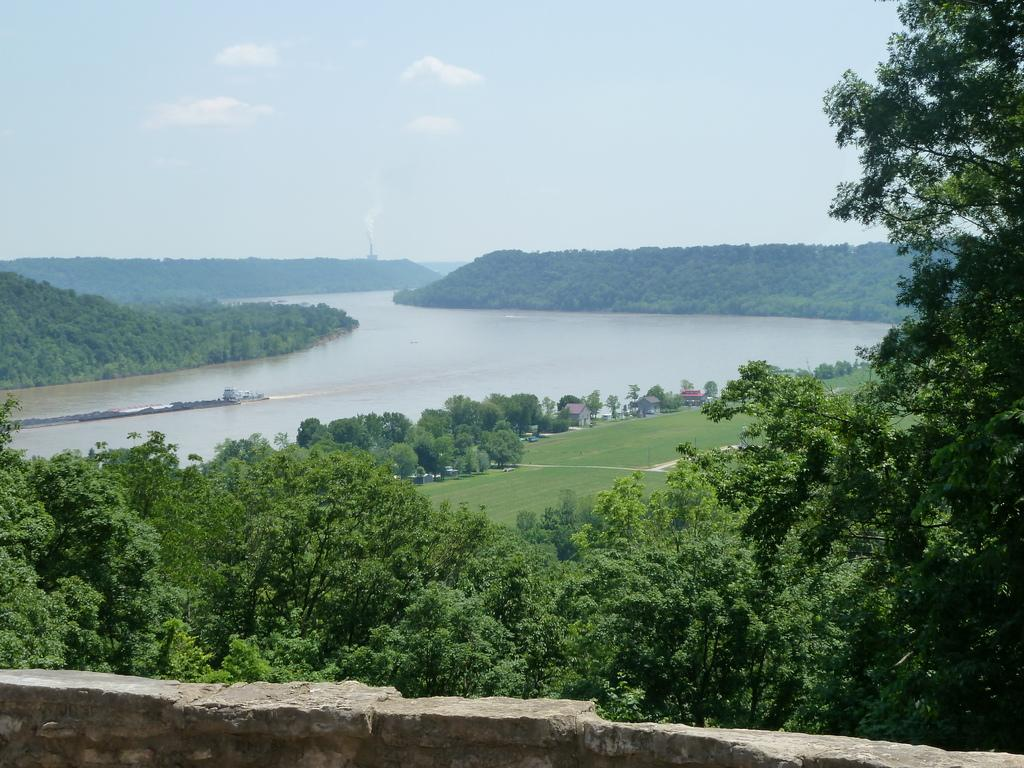What type of vegetation can be seen in the image? There are trees and grass in the image. What type of structures are visible in the image? There are buildings in the image. What natural feature is present in the image? There is a water body in the image. What is the lowest visible element in the image? There is a boundary wall at the bottom of the image. What is visible above the ground in the image? The sky is visible in the image. What can be seen in the sky? Clouds are present in the sky. What type of sweater is the family wearing in the image? There is no family or sweater present in the image. What type of wall is separating the water body from the grass in the image? There is no wall separating the water body from the grass in the image. 